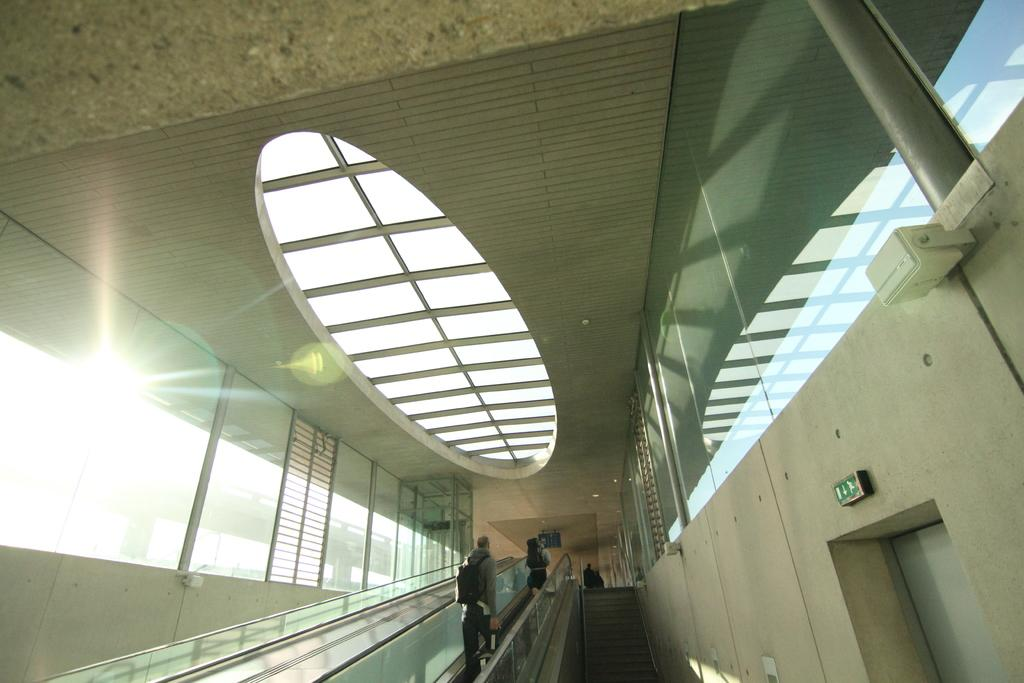What are the two people in the image doing? The two people are on an escalator in the image. What type of material can be seen in the background of the image? There are glass windows in the image. Where is the sun located in the image? The sun is visible on the left side of the image. What type of acoustics can be heard in the image? There is no information about sounds or acoustics in the image, so it cannot be determined. How many kittens are visible in the image? There are no kittens present in the image. 